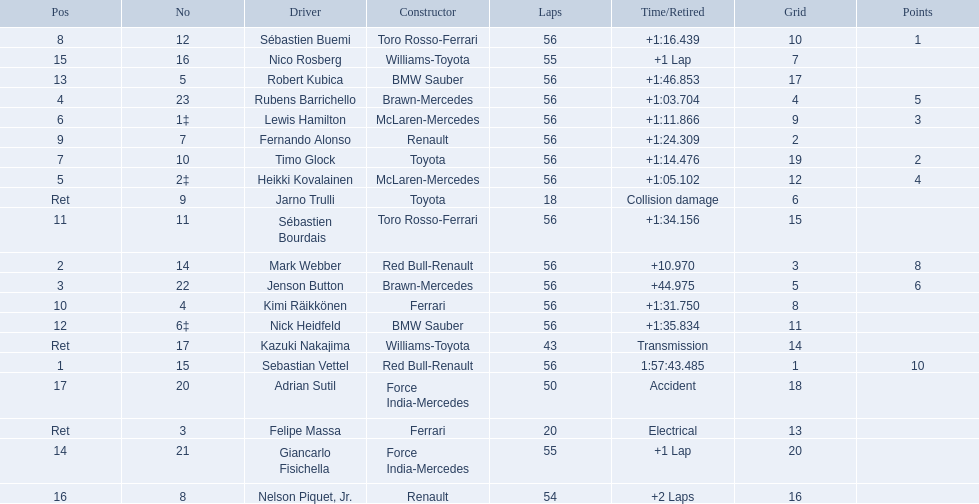Who are all the drivers? Sebastian Vettel, Mark Webber, Jenson Button, Rubens Barrichello, Heikki Kovalainen, Lewis Hamilton, Timo Glock, Sébastien Buemi, Fernando Alonso, Kimi Räikkönen, Sébastien Bourdais, Nick Heidfeld, Robert Kubica, Giancarlo Fisichella, Nico Rosberg, Nelson Piquet, Jr., Adrian Sutil, Kazuki Nakajima, Felipe Massa, Jarno Trulli. What were their finishing times? 1:57:43.485, +10.970, +44.975, +1:03.704, +1:05.102, +1:11.866, +1:14.476, +1:16.439, +1:24.309, +1:31.750, +1:34.156, +1:35.834, +1:46.853, +1 Lap, +1 Lap, +2 Laps, Accident, Transmission, Electrical, Collision damage. Who finished last? Robert Kubica. 